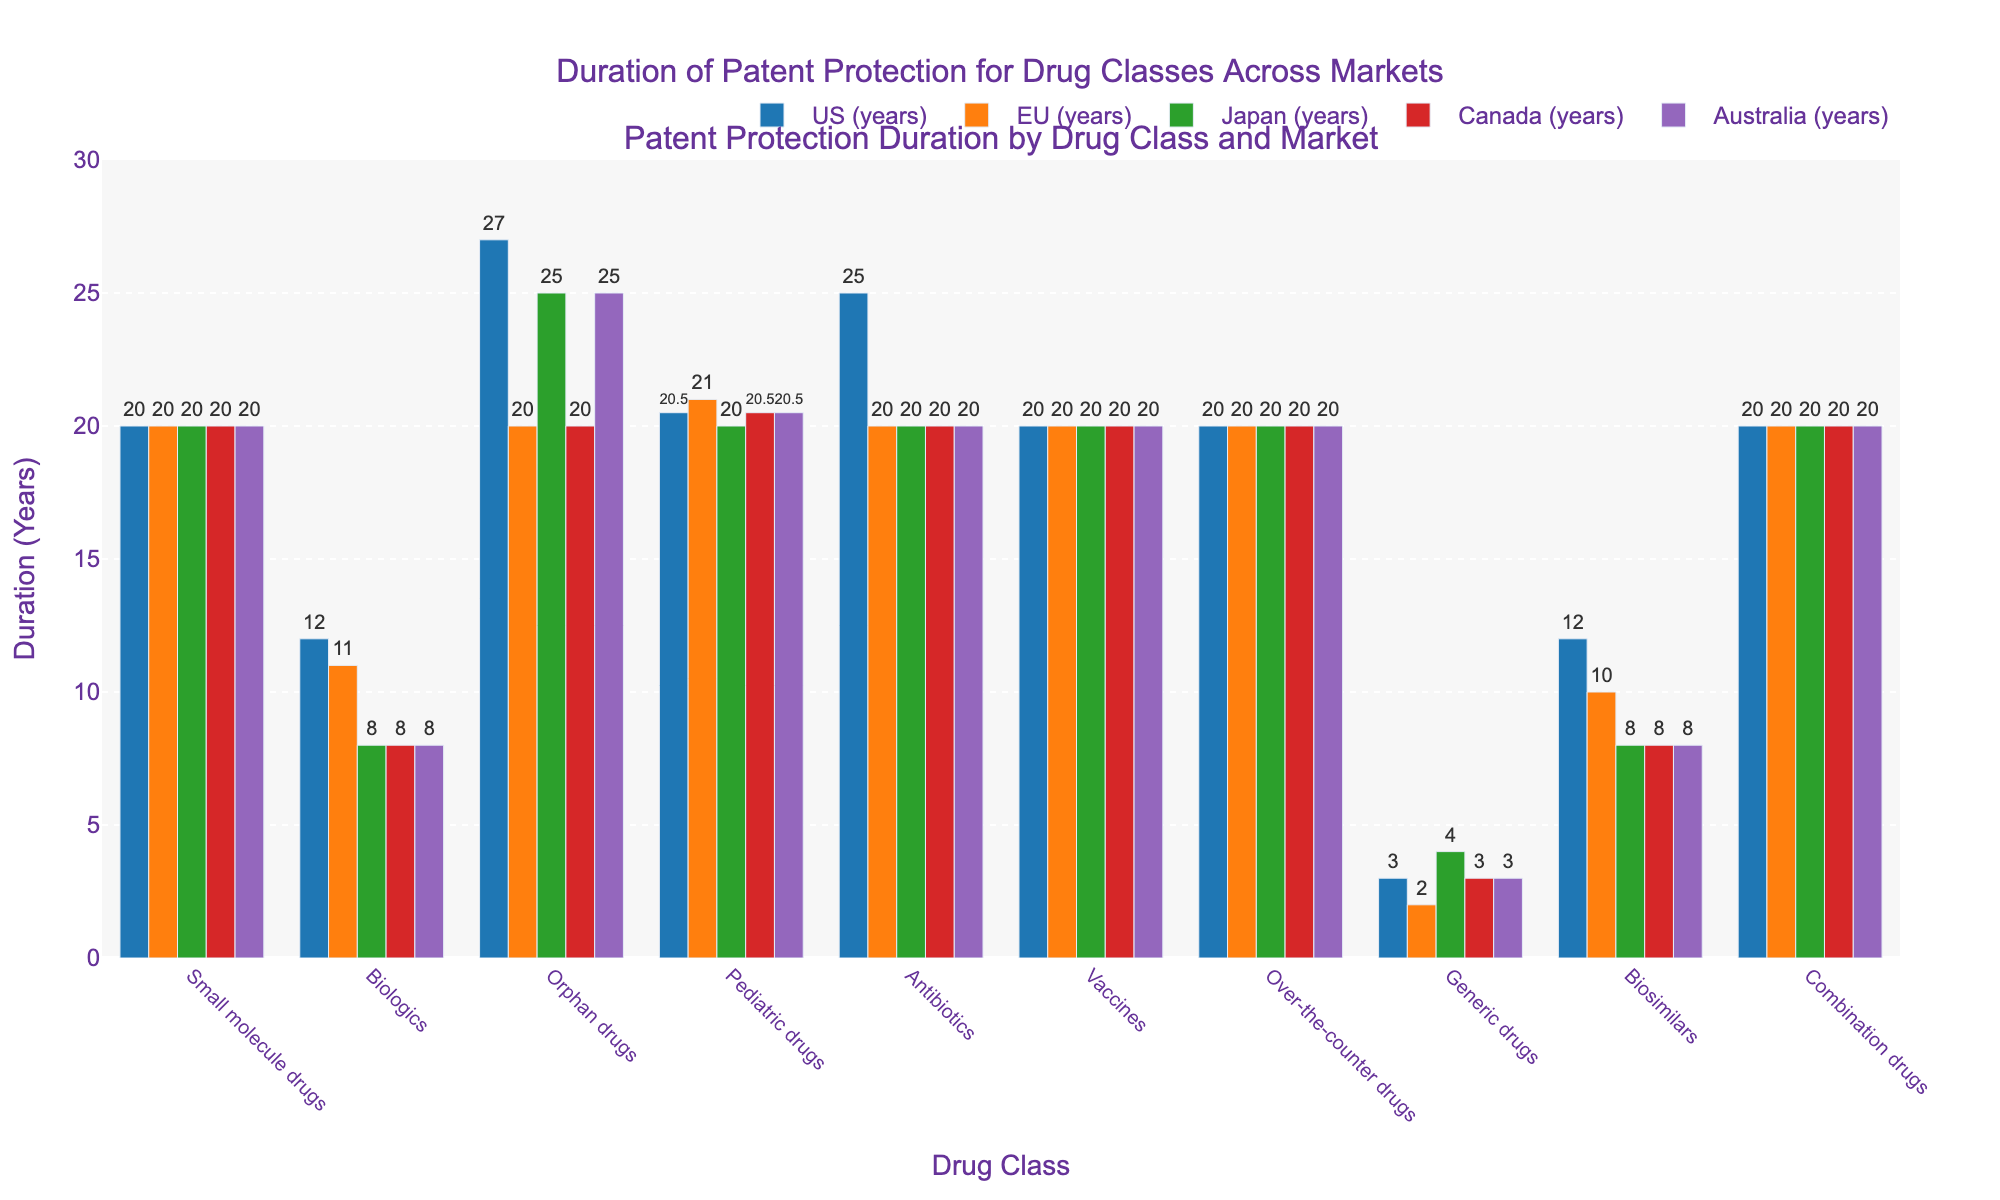What's the total duration of patent protection for Orphan drugs in the US and Japan? In the figure, locate the bars representing Orphan drugs for the US and Japan. The US duration is 27 years and Japan duration is 25 years. Summing them up, we get 27 + 25 = 52.
Answer: 52 Which drug class has the shortest duration of patent protection in Canada? Find the shortest bar for the Canada market. Generic drugs have the shortest duration with 3 years.
Answer: Generic drugs Does any drug class have the same patent protection duration across all markets? Look for bars of the same height for each drug class across all markets. Small molecule drugs, Vaccines, Over-the-counter drugs, and Combination drugs have uniform durations of 20 years in all markets.
Answer: Yes What is the difference in the duration of patent protection for Biologics between the US and Australia? Check the heights of the bars for Biologics in the US and Australia. The duration in the US is 12 years, while in Australia it is 8 years. The difference is 12 - 8 = 4.
Answer: 4 How does the average duration of patent protection for Pediatric drugs compare across all markets? Calculate the average duration for Pediatric drugs by adding the durations for all markets and dividing by the number of markets. The sums are 20.5 + 21 + 20 + 20.5 + 20.5 = 102.5. The average is 102.5 / 5 = 20.5.
Answer: 20.5 Which market offers the longest patent protection for Antibiotics? Identify the tallest bar for Antibiotics. The US market offers the longest duration of 25 years.
Answer: US Compare the patent protection duration of Biosimilars and Generic drugs in Japan. How much longer is one than the other? Biosimilars have a duration of 8 years in Japan, while Generic drugs have 4 years. The difference is 8 - 4 = 4.
Answer: 4 Which drug class has the most consistent duration of patent protection across all markets? Identify the drug class with bars of the same height across all markets. Both Vaccines and Combination drugs have consistent durations of 20 years in all markets.
Answer: Vaccines and Combination drugs Is the duration of patent protection for Small molecule drugs higher than for Biosimilars in the EU? Compare the heights of the bars for Small molecule drugs and Biosimilars in the EU. Small molecule drugs have 20 years, while Biosimilars have 10 years. Thus, Small molecule drugs have more.
Answer: Yes 